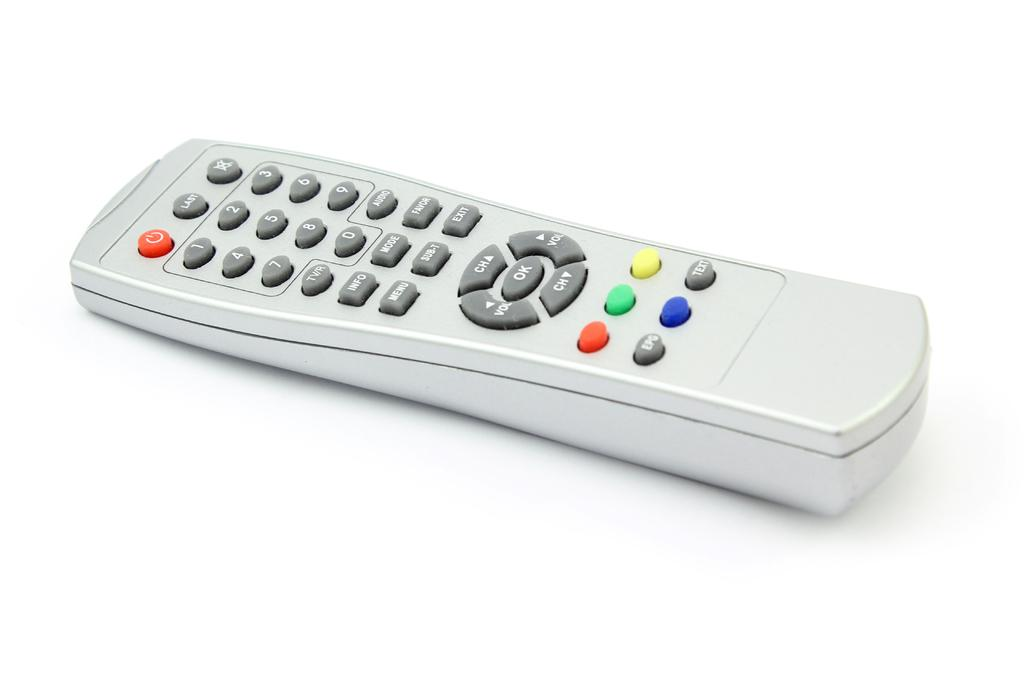<image>
Summarize the visual content of the image. A white TV remote control has  buttons for volume and channel. 